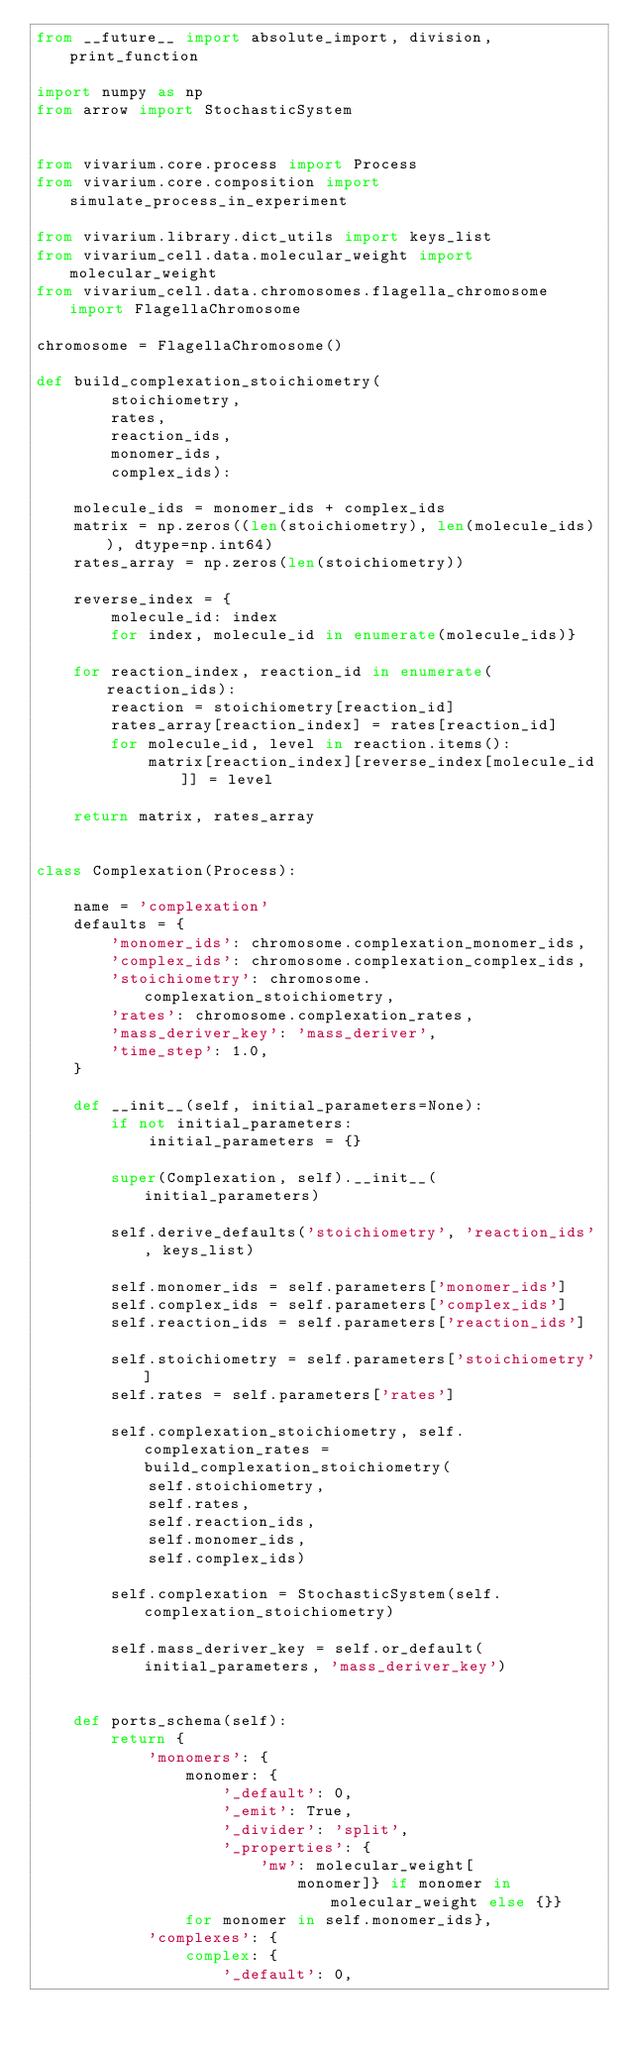Convert code to text. <code><loc_0><loc_0><loc_500><loc_500><_Python_>from __future__ import absolute_import, division, print_function

import numpy as np
from arrow import StochasticSystem


from vivarium.core.process import Process
from vivarium.core.composition import simulate_process_in_experiment

from vivarium.library.dict_utils import keys_list
from vivarium_cell.data.molecular_weight import molecular_weight
from vivarium_cell.data.chromosomes.flagella_chromosome import FlagellaChromosome

chromosome = FlagellaChromosome()

def build_complexation_stoichiometry(
        stoichiometry,
        rates,
        reaction_ids,
        monomer_ids,
        complex_ids):

    molecule_ids = monomer_ids + complex_ids
    matrix = np.zeros((len(stoichiometry), len(molecule_ids)), dtype=np.int64)
    rates_array = np.zeros(len(stoichiometry))

    reverse_index = {
        molecule_id: index
        for index, molecule_id in enumerate(molecule_ids)}

    for reaction_index, reaction_id in enumerate(reaction_ids):
        reaction = stoichiometry[reaction_id]
        rates_array[reaction_index] = rates[reaction_id]
        for molecule_id, level in reaction.items():
            matrix[reaction_index][reverse_index[molecule_id]] = level

    return matrix, rates_array


class Complexation(Process):

    name = 'complexation'
    defaults = {
        'monomer_ids': chromosome.complexation_monomer_ids,
        'complex_ids': chromosome.complexation_complex_ids,
        'stoichiometry': chromosome.complexation_stoichiometry,
        'rates': chromosome.complexation_rates,
        'mass_deriver_key': 'mass_deriver',
        'time_step': 1.0,
    }

    def __init__(self, initial_parameters=None):
        if not initial_parameters:
            initial_parameters = {}

        super(Complexation, self).__init__(initial_parameters)

        self.derive_defaults('stoichiometry', 'reaction_ids', keys_list)

        self.monomer_ids = self.parameters['monomer_ids']
        self.complex_ids = self.parameters['complex_ids']
        self.reaction_ids = self.parameters['reaction_ids']

        self.stoichiometry = self.parameters['stoichiometry']
        self.rates = self.parameters['rates']

        self.complexation_stoichiometry, self.complexation_rates = build_complexation_stoichiometry(
            self.stoichiometry,
            self.rates,
            self.reaction_ids,
            self.monomer_ids,
            self.complex_ids)

        self.complexation = StochasticSystem(self.complexation_stoichiometry)

        self.mass_deriver_key = self.or_default(initial_parameters, 'mass_deriver_key')


    def ports_schema(self):
        return {
            'monomers': {
                monomer: {
                    '_default': 0,
                    '_emit': True,
                    '_divider': 'split',
                    '_properties': {
                        'mw': molecular_weight[
                            monomer]} if monomer in molecular_weight else {}}
                for monomer in self.monomer_ids},
            'complexes': {
                complex: {
                    '_default': 0,</code> 